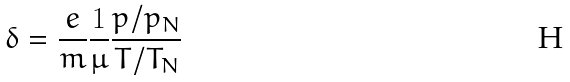Convert formula to latex. <formula><loc_0><loc_0><loc_500><loc_500>\delta = \frac { e } { m } \frac { 1 } { \mu } \frac { p / p _ { N } } { T / T _ { N } }</formula> 